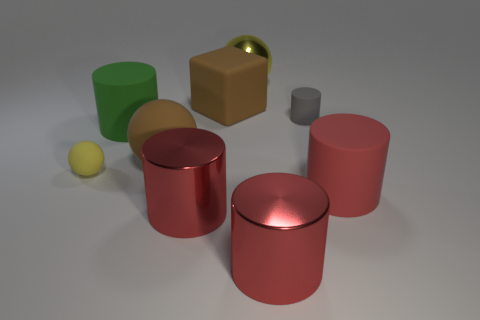Is the color of the tiny ball the same as the large sphere that is to the left of the big cube?
Your answer should be very brief. No. How many objects are large brown objects behind the large green cylinder or cylinders that are behind the tiny sphere?
Your answer should be compact. 3. There is a block that is the same size as the green matte cylinder; what material is it?
Keep it short and to the point. Rubber. How many other things are there of the same material as the small yellow thing?
Offer a terse response. 5. There is a large metallic thing that is behind the red matte thing; does it have the same shape as the rubber thing left of the large green cylinder?
Make the answer very short. Yes. What is the color of the matte cylinder on the left side of the small object behind the large cylinder that is behind the yellow rubber ball?
Provide a short and direct response. Green. How many other objects are the same color as the rubber block?
Offer a terse response. 1. Are there fewer gray matte spheres than big matte cylinders?
Offer a very short reply. Yes. There is a cylinder that is both behind the yellow rubber sphere and left of the tiny gray matte cylinder; what color is it?
Keep it short and to the point. Green. What is the material of the brown thing that is the same shape as the yellow matte thing?
Keep it short and to the point. Rubber. 